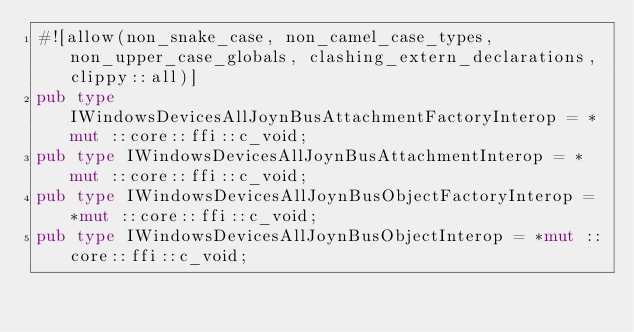<code> <loc_0><loc_0><loc_500><loc_500><_Rust_>#![allow(non_snake_case, non_camel_case_types, non_upper_case_globals, clashing_extern_declarations, clippy::all)]
pub type IWindowsDevicesAllJoynBusAttachmentFactoryInterop = *mut ::core::ffi::c_void;
pub type IWindowsDevicesAllJoynBusAttachmentInterop = *mut ::core::ffi::c_void;
pub type IWindowsDevicesAllJoynBusObjectFactoryInterop = *mut ::core::ffi::c_void;
pub type IWindowsDevicesAllJoynBusObjectInterop = *mut ::core::ffi::c_void;
</code> 